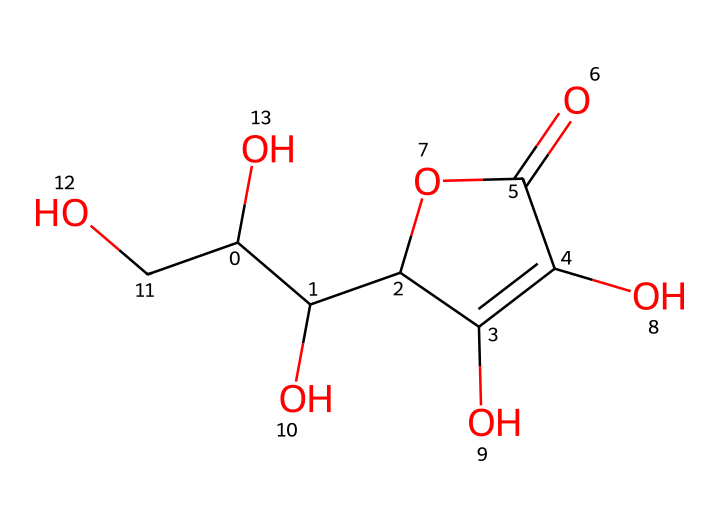What is the name of this chemical? The SMILES representation corresponds to ascorbic acid, commonly known as vitamin C. The structure indicates it has multiple hydroxyl (–OH) groups and a lactone functional group, which are characteristic of vitamin C.
Answer: ascorbic acid How many carbon atoms are in the structure? By examining the SMILES notation, we can count the carbon atoms. There are six carbon atoms represented in the structure, which contributes to the overall composition of vitamin C.
Answer: six What type of bond connects the carbon rings in this structure? The structure shows a combination of single and double bonds. Specifically, the bonds connecting the carbon atoms in the ring structure include a double bond (as seen in C1=C), indicating that it is a ring compound with unsaturation.
Answer: double bond How many hydroxyl (–OH) groups are present? By analyzing the structure, we can identify the hydroxyl groups, which appear as –OH. There are four hydroxyl groups present in the structure of vitamin C, which contribute to its solubility in water.
Answer: four Is this compound hydrophilic or hydrophobic? Given the presence of multiple hydroxyl groups, which are polar, we can conclude that vitamin C is hydrophilic, meaning it interacts well with water.
Answer: hydrophilic What does the cage structure in the compound imply? In this context, the term "cage structure" often refers to a chemical having a complex arrangement of its atoms that can encapsulate or stabilize other molecules or ions. In ascorbic acid, the arrangement of bonds and rings reflects a stable structure beneficial for biological function.
Answer: stability What type of molecule is vitamin C classified as? Vitamin C (ascorbic acid) is classified as a vitamin and is specifically an antioxidant due to its ability to neutralize free radicals, which can damage cells. This classification highlights its functional importance in biology.
Answer: vitamin 